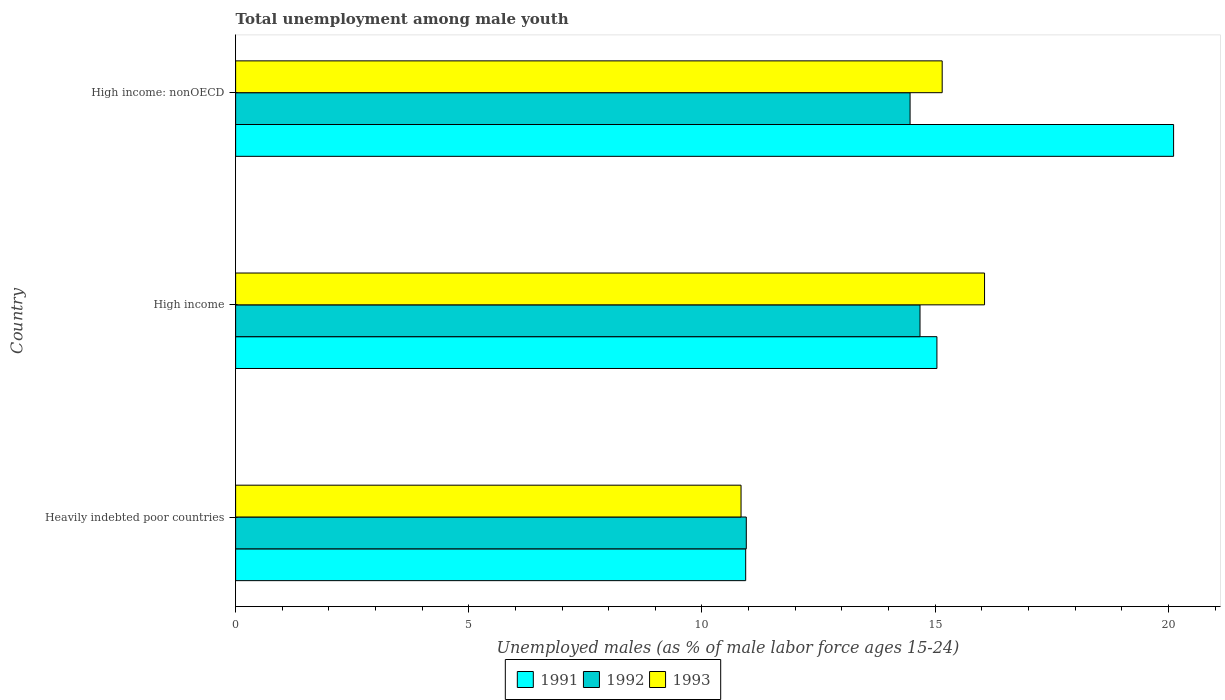Are the number of bars on each tick of the Y-axis equal?
Give a very brief answer. Yes. How many bars are there on the 2nd tick from the bottom?
Offer a terse response. 3. What is the label of the 1st group of bars from the top?
Ensure brevity in your answer.  High income: nonOECD. What is the percentage of unemployed males in in 1993 in High income: nonOECD?
Your answer should be very brief. 15.15. Across all countries, what is the maximum percentage of unemployed males in in 1993?
Make the answer very short. 16.06. Across all countries, what is the minimum percentage of unemployed males in in 1991?
Your answer should be compact. 10.94. In which country was the percentage of unemployed males in in 1991 maximum?
Provide a succinct answer. High income: nonOECD. In which country was the percentage of unemployed males in in 1991 minimum?
Offer a very short reply. Heavily indebted poor countries. What is the total percentage of unemployed males in in 1991 in the graph?
Your answer should be compact. 46.09. What is the difference between the percentage of unemployed males in in 1991 in High income and that in High income: nonOECD?
Provide a succinct answer. -5.07. What is the difference between the percentage of unemployed males in in 1993 in Heavily indebted poor countries and the percentage of unemployed males in in 1992 in High income?
Your response must be concise. -3.84. What is the average percentage of unemployed males in in 1991 per country?
Keep it short and to the point. 15.36. What is the difference between the percentage of unemployed males in in 1991 and percentage of unemployed males in in 1993 in High income: nonOECD?
Offer a terse response. 4.96. What is the ratio of the percentage of unemployed males in in 1992 in Heavily indebted poor countries to that in High income: nonOECD?
Your answer should be compact. 0.76. Is the percentage of unemployed males in in 1993 in Heavily indebted poor countries less than that in High income?
Ensure brevity in your answer.  Yes. What is the difference between the highest and the second highest percentage of unemployed males in in 1992?
Your answer should be very brief. 0.21. What is the difference between the highest and the lowest percentage of unemployed males in in 1991?
Provide a short and direct response. 9.18. What does the 1st bar from the top in High income: nonOECD represents?
Provide a short and direct response. 1993. What does the 1st bar from the bottom in High income represents?
Give a very brief answer. 1991. Is it the case that in every country, the sum of the percentage of unemployed males in in 1993 and percentage of unemployed males in in 1991 is greater than the percentage of unemployed males in in 1992?
Provide a short and direct response. Yes. Are all the bars in the graph horizontal?
Your answer should be very brief. Yes. What is the difference between two consecutive major ticks on the X-axis?
Give a very brief answer. 5. Does the graph contain any zero values?
Make the answer very short. No. Does the graph contain grids?
Keep it short and to the point. No. Where does the legend appear in the graph?
Your response must be concise. Bottom center. How many legend labels are there?
Provide a short and direct response. 3. What is the title of the graph?
Make the answer very short. Total unemployment among male youth. Does "2004" appear as one of the legend labels in the graph?
Keep it short and to the point. No. What is the label or title of the X-axis?
Provide a succinct answer. Unemployed males (as % of male labor force ages 15-24). What is the label or title of the Y-axis?
Your answer should be very brief. Country. What is the Unemployed males (as % of male labor force ages 15-24) in 1991 in Heavily indebted poor countries?
Offer a very short reply. 10.94. What is the Unemployed males (as % of male labor force ages 15-24) in 1992 in Heavily indebted poor countries?
Your answer should be very brief. 10.95. What is the Unemployed males (as % of male labor force ages 15-24) in 1993 in Heavily indebted poor countries?
Give a very brief answer. 10.84. What is the Unemployed males (as % of male labor force ages 15-24) of 1991 in High income?
Ensure brevity in your answer.  15.04. What is the Unemployed males (as % of male labor force ages 15-24) of 1992 in High income?
Your answer should be very brief. 14.67. What is the Unemployed males (as % of male labor force ages 15-24) of 1993 in High income?
Your answer should be compact. 16.06. What is the Unemployed males (as % of male labor force ages 15-24) in 1991 in High income: nonOECD?
Ensure brevity in your answer.  20.11. What is the Unemployed males (as % of male labor force ages 15-24) in 1992 in High income: nonOECD?
Offer a terse response. 14.46. What is the Unemployed males (as % of male labor force ages 15-24) of 1993 in High income: nonOECD?
Give a very brief answer. 15.15. Across all countries, what is the maximum Unemployed males (as % of male labor force ages 15-24) of 1991?
Provide a succinct answer. 20.11. Across all countries, what is the maximum Unemployed males (as % of male labor force ages 15-24) of 1992?
Your response must be concise. 14.67. Across all countries, what is the maximum Unemployed males (as % of male labor force ages 15-24) in 1993?
Offer a very short reply. 16.06. Across all countries, what is the minimum Unemployed males (as % of male labor force ages 15-24) in 1991?
Give a very brief answer. 10.94. Across all countries, what is the minimum Unemployed males (as % of male labor force ages 15-24) of 1992?
Keep it short and to the point. 10.95. Across all countries, what is the minimum Unemployed males (as % of male labor force ages 15-24) in 1993?
Your response must be concise. 10.84. What is the total Unemployed males (as % of male labor force ages 15-24) in 1991 in the graph?
Offer a very short reply. 46.09. What is the total Unemployed males (as % of male labor force ages 15-24) of 1992 in the graph?
Ensure brevity in your answer.  40.09. What is the total Unemployed males (as % of male labor force ages 15-24) in 1993 in the graph?
Keep it short and to the point. 42.05. What is the difference between the Unemployed males (as % of male labor force ages 15-24) in 1991 in Heavily indebted poor countries and that in High income?
Your answer should be compact. -4.1. What is the difference between the Unemployed males (as % of male labor force ages 15-24) in 1992 in Heavily indebted poor countries and that in High income?
Offer a terse response. -3.72. What is the difference between the Unemployed males (as % of male labor force ages 15-24) of 1993 in Heavily indebted poor countries and that in High income?
Provide a short and direct response. -5.22. What is the difference between the Unemployed males (as % of male labor force ages 15-24) of 1991 in Heavily indebted poor countries and that in High income: nonOECD?
Provide a succinct answer. -9.18. What is the difference between the Unemployed males (as % of male labor force ages 15-24) in 1992 in Heavily indebted poor countries and that in High income: nonOECD?
Make the answer very short. -3.51. What is the difference between the Unemployed males (as % of male labor force ages 15-24) in 1993 in Heavily indebted poor countries and that in High income: nonOECD?
Your response must be concise. -4.31. What is the difference between the Unemployed males (as % of male labor force ages 15-24) in 1991 in High income and that in High income: nonOECD?
Offer a terse response. -5.07. What is the difference between the Unemployed males (as % of male labor force ages 15-24) in 1992 in High income and that in High income: nonOECD?
Ensure brevity in your answer.  0.21. What is the difference between the Unemployed males (as % of male labor force ages 15-24) of 1993 in High income and that in High income: nonOECD?
Your answer should be very brief. 0.91. What is the difference between the Unemployed males (as % of male labor force ages 15-24) of 1991 in Heavily indebted poor countries and the Unemployed males (as % of male labor force ages 15-24) of 1992 in High income?
Your response must be concise. -3.74. What is the difference between the Unemployed males (as % of male labor force ages 15-24) of 1991 in Heavily indebted poor countries and the Unemployed males (as % of male labor force ages 15-24) of 1993 in High income?
Your answer should be compact. -5.12. What is the difference between the Unemployed males (as % of male labor force ages 15-24) of 1992 in Heavily indebted poor countries and the Unemployed males (as % of male labor force ages 15-24) of 1993 in High income?
Your answer should be very brief. -5.11. What is the difference between the Unemployed males (as % of male labor force ages 15-24) in 1991 in Heavily indebted poor countries and the Unemployed males (as % of male labor force ages 15-24) in 1992 in High income: nonOECD?
Keep it short and to the point. -3.52. What is the difference between the Unemployed males (as % of male labor force ages 15-24) in 1991 in Heavily indebted poor countries and the Unemployed males (as % of male labor force ages 15-24) in 1993 in High income: nonOECD?
Your answer should be very brief. -4.21. What is the difference between the Unemployed males (as % of male labor force ages 15-24) of 1992 in Heavily indebted poor countries and the Unemployed males (as % of male labor force ages 15-24) of 1993 in High income: nonOECD?
Keep it short and to the point. -4.2. What is the difference between the Unemployed males (as % of male labor force ages 15-24) in 1991 in High income and the Unemployed males (as % of male labor force ages 15-24) in 1992 in High income: nonOECD?
Your answer should be very brief. 0.58. What is the difference between the Unemployed males (as % of male labor force ages 15-24) of 1991 in High income and the Unemployed males (as % of male labor force ages 15-24) of 1993 in High income: nonOECD?
Your answer should be compact. -0.11. What is the difference between the Unemployed males (as % of male labor force ages 15-24) of 1992 in High income and the Unemployed males (as % of male labor force ages 15-24) of 1993 in High income: nonOECD?
Provide a succinct answer. -0.48. What is the average Unemployed males (as % of male labor force ages 15-24) in 1991 per country?
Keep it short and to the point. 15.36. What is the average Unemployed males (as % of male labor force ages 15-24) of 1992 per country?
Offer a terse response. 13.36. What is the average Unemployed males (as % of male labor force ages 15-24) in 1993 per country?
Your answer should be compact. 14.02. What is the difference between the Unemployed males (as % of male labor force ages 15-24) in 1991 and Unemployed males (as % of male labor force ages 15-24) in 1992 in Heavily indebted poor countries?
Offer a terse response. -0.01. What is the difference between the Unemployed males (as % of male labor force ages 15-24) of 1991 and Unemployed males (as % of male labor force ages 15-24) of 1993 in Heavily indebted poor countries?
Make the answer very short. 0.1. What is the difference between the Unemployed males (as % of male labor force ages 15-24) in 1992 and Unemployed males (as % of male labor force ages 15-24) in 1993 in Heavily indebted poor countries?
Offer a very short reply. 0.11. What is the difference between the Unemployed males (as % of male labor force ages 15-24) of 1991 and Unemployed males (as % of male labor force ages 15-24) of 1992 in High income?
Provide a succinct answer. 0.36. What is the difference between the Unemployed males (as % of male labor force ages 15-24) in 1991 and Unemployed males (as % of male labor force ages 15-24) in 1993 in High income?
Provide a short and direct response. -1.02. What is the difference between the Unemployed males (as % of male labor force ages 15-24) in 1992 and Unemployed males (as % of male labor force ages 15-24) in 1993 in High income?
Keep it short and to the point. -1.38. What is the difference between the Unemployed males (as % of male labor force ages 15-24) of 1991 and Unemployed males (as % of male labor force ages 15-24) of 1992 in High income: nonOECD?
Your response must be concise. 5.65. What is the difference between the Unemployed males (as % of male labor force ages 15-24) of 1991 and Unemployed males (as % of male labor force ages 15-24) of 1993 in High income: nonOECD?
Give a very brief answer. 4.96. What is the difference between the Unemployed males (as % of male labor force ages 15-24) of 1992 and Unemployed males (as % of male labor force ages 15-24) of 1993 in High income: nonOECD?
Offer a very short reply. -0.69. What is the ratio of the Unemployed males (as % of male labor force ages 15-24) of 1991 in Heavily indebted poor countries to that in High income?
Make the answer very short. 0.73. What is the ratio of the Unemployed males (as % of male labor force ages 15-24) of 1992 in Heavily indebted poor countries to that in High income?
Your answer should be compact. 0.75. What is the ratio of the Unemployed males (as % of male labor force ages 15-24) of 1993 in Heavily indebted poor countries to that in High income?
Give a very brief answer. 0.67. What is the ratio of the Unemployed males (as % of male labor force ages 15-24) of 1991 in Heavily indebted poor countries to that in High income: nonOECD?
Provide a succinct answer. 0.54. What is the ratio of the Unemployed males (as % of male labor force ages 15-24) in 1992 in Heavily indebted poor countries to that in High income: nonOECD?
Ensure brevity in your answer.  0.76. What is the ratio of the Unemployed males (as % of male labor force ages 15-24) in 1993 in Heavily indebted poor countries to that in High income: nonOECD?
Your response must be concise. 0.72. What is the ratio of the Unemployed males (as % of male labor force ages 15-24) of 1991 in High income to that in High income: nonOECD?
Ensure brevity in your answer.  0.75. What is the ratio of the Unemployed males (as % of male labor force ages 15-24) of 1992 in High income to that in High income: nonOECD?
Your answer should be compact. 1.01. What is the ratio of the Unemployed males (as % of male labor force ages 15-24) in 1993 in High income to that in High income: nonOECD?
Make the answer very short. 1.06. What is the difference between the highest and the second highest Unemployed males (as % of male labor force ages 15-24) of 1991?
Your answer should be compact. 5.07. What is the difference between the highest and the second highest Unemployed males (as % of male labor force ages 15-24) of 1992?
Give a very brief answer. 0.21. What is the difference between the highest and the second highest Unemployed males (as % of male labor force ages 15-24) in 1993?
Your answer should be very brief. 0.91. What is the difference between the highest and the lowest Unemployed males (as % of male labor force ages 15-24) of 1991?
Keep it short and to the point. 9.18. What is the difference between the highest and the lowest Unemployed males (as % of male labor force ages 15-24) of 1992?
Your response must be concise. 3.72. What is the difference between the highest and the lowest Unemployed males (as % of male labor force ages 15-24) in 1993?
Offer a terse response. 5.22. 